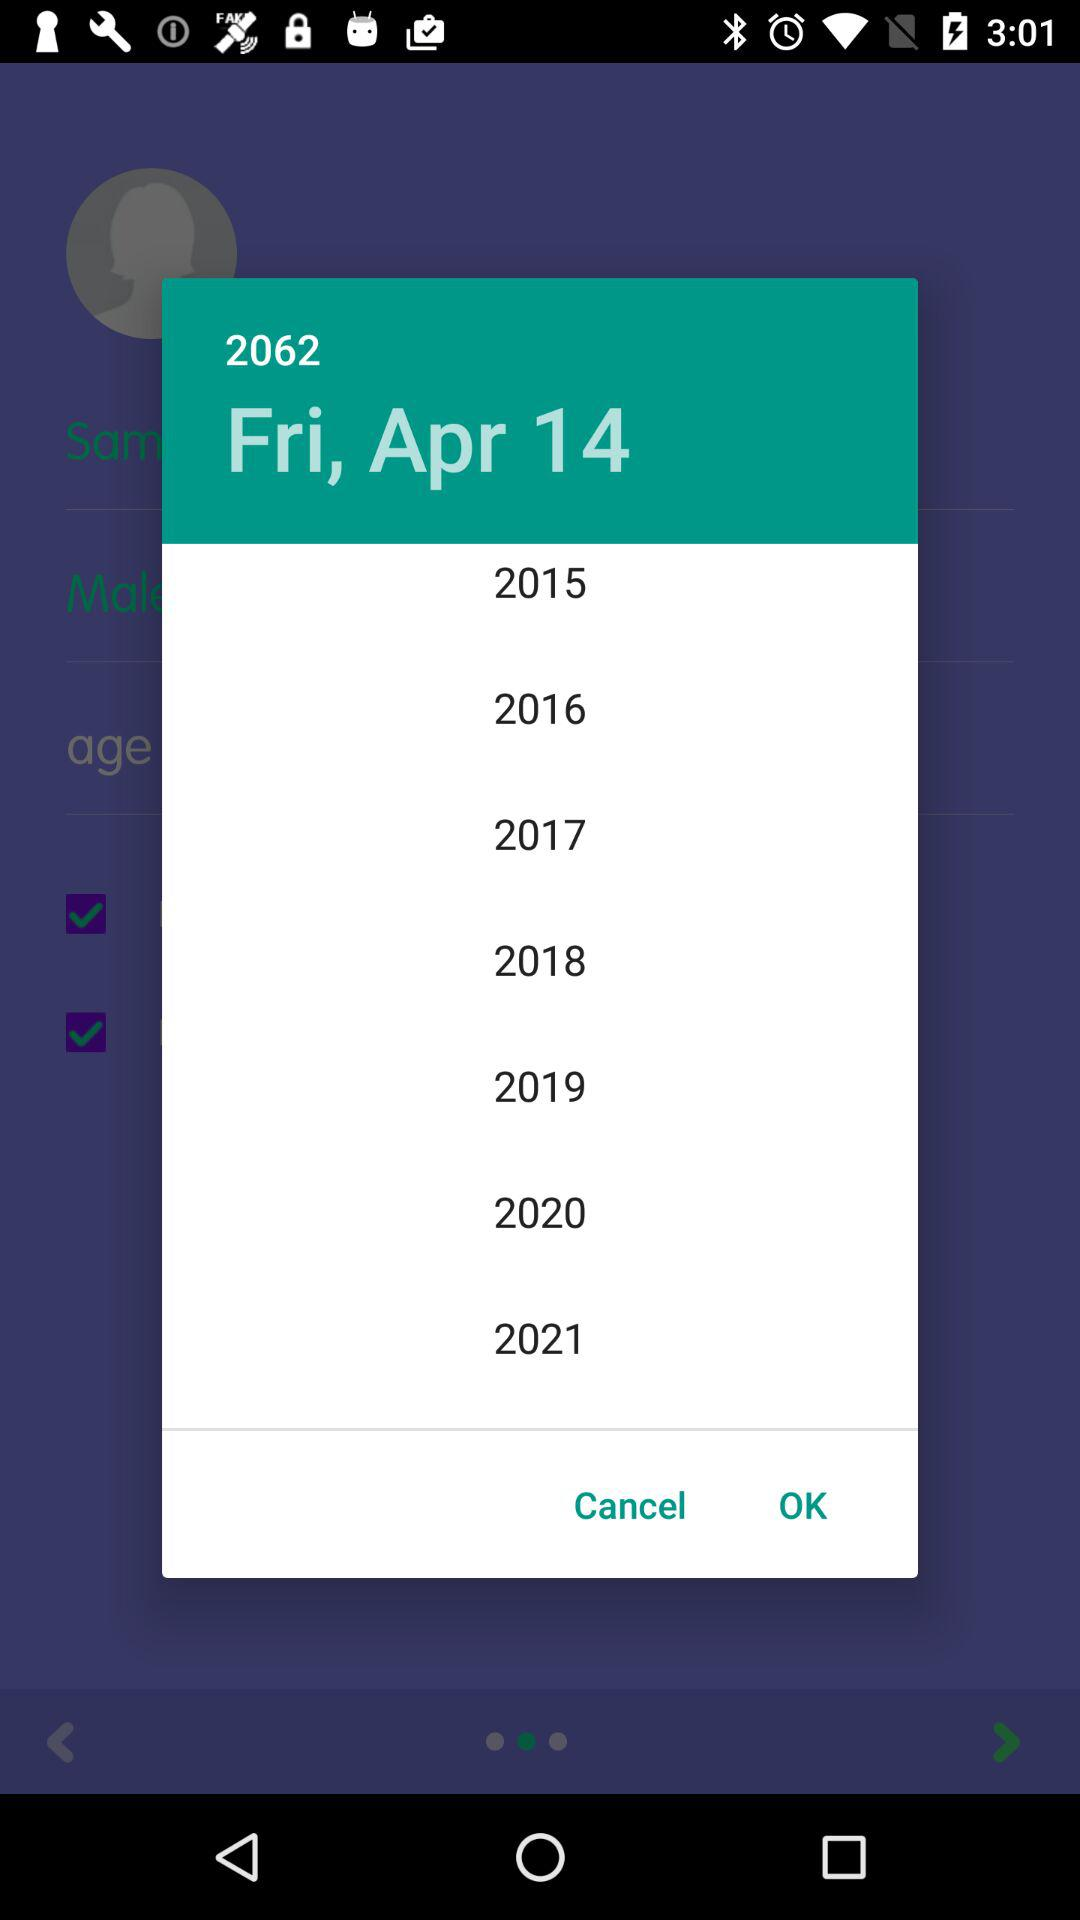What day is it on the selected date? It is Friday on the selected date. 